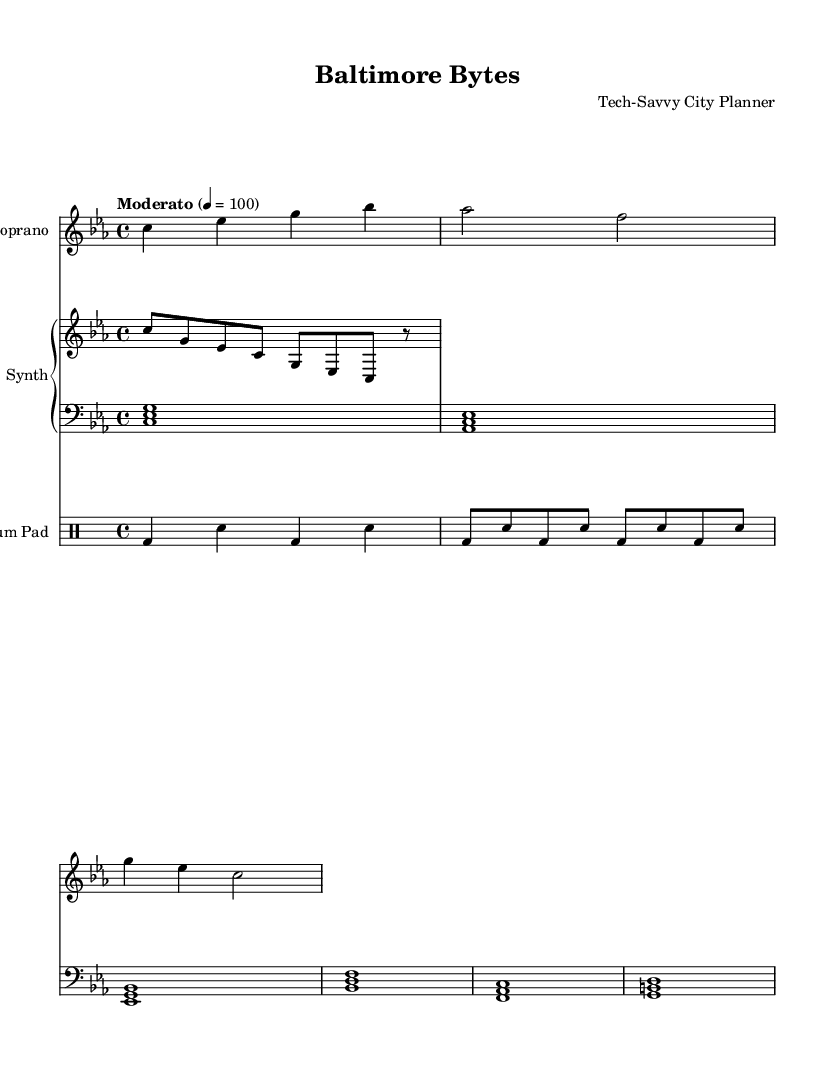What is the key signature of this music? The key signature is indicated at the beginning of the music, which shows it is in C minor, having three flats (B♭, E♭, A♭).
Answer: C minor What is the time signature of the piece? The time signature is located after the key signature and indicates how many beats are in each measure. In this case, it is 4/4, meaning there are four beats per measure.
Answer: 4/4 What is the tempo marking of the piece? The tempo marking appears beneath the time signature and indicates the speed of the music. Here, it states "Moderato" with a metronome marking of 100 beats per minute.
Answer: Moderato, 100 How many beats does the drum pad play in the first measure? The drum pad notation shows a bass drum (bd) followed by a snare (sn) in alternating fashion, producing a total of four beats (1 bd and 1 sn per beat) in the first measure.
Answer: 4 Which instruments are used in this opera composition? The composition includes a soprano voice, synthesizer (with upper and lower sections), and a drum pad. These are indicated by the distinct staff labels in the score.
Answer: Soprano, synthesizer, drum pad What is the function of the synthesizer in this piece? The synthesizer layers both an upper melody and a lower harmonic support, providing a rich electronic texture that complements the vocal line, as seen in its two separate staves labeled "upper" and "lower".
Answer: Melody and harmony What thematic element is reflected in the soprano lyrics? The lyrics reflect a modern urban theme with references to digitality and concrete, aligning with the title "Baltimore Bytes" which suggests a connection to a technological and urban landscape.
Answer: Digital dreams, concrete streams 